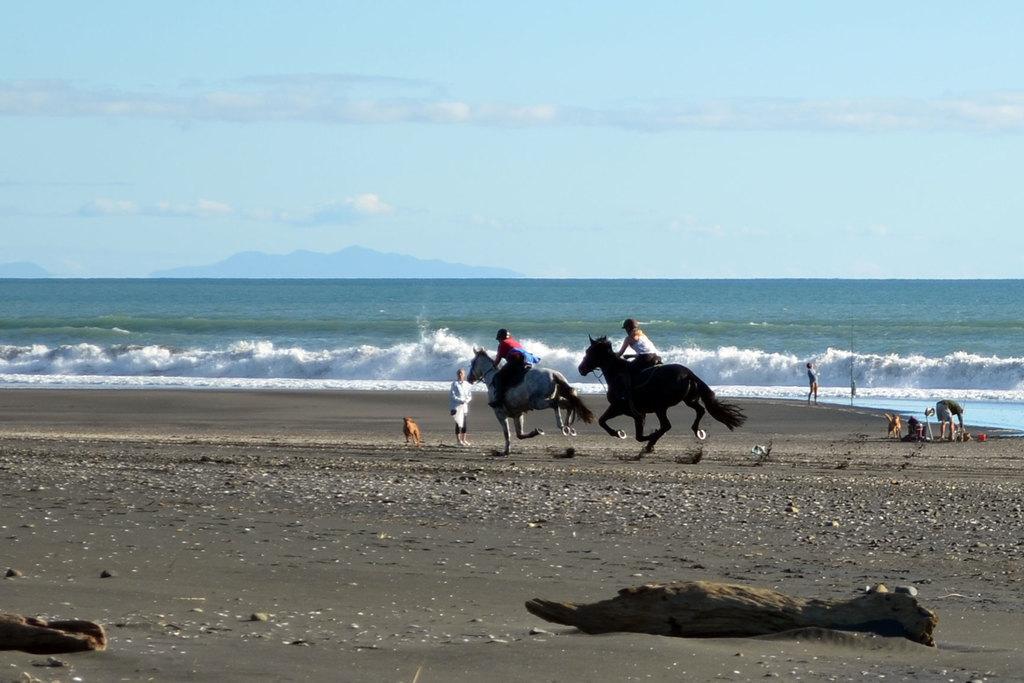In one or two sentences, can you explain what this image depicts? Here 2 persons are riding the horses, this is water, at the top it's a sunny sky. 